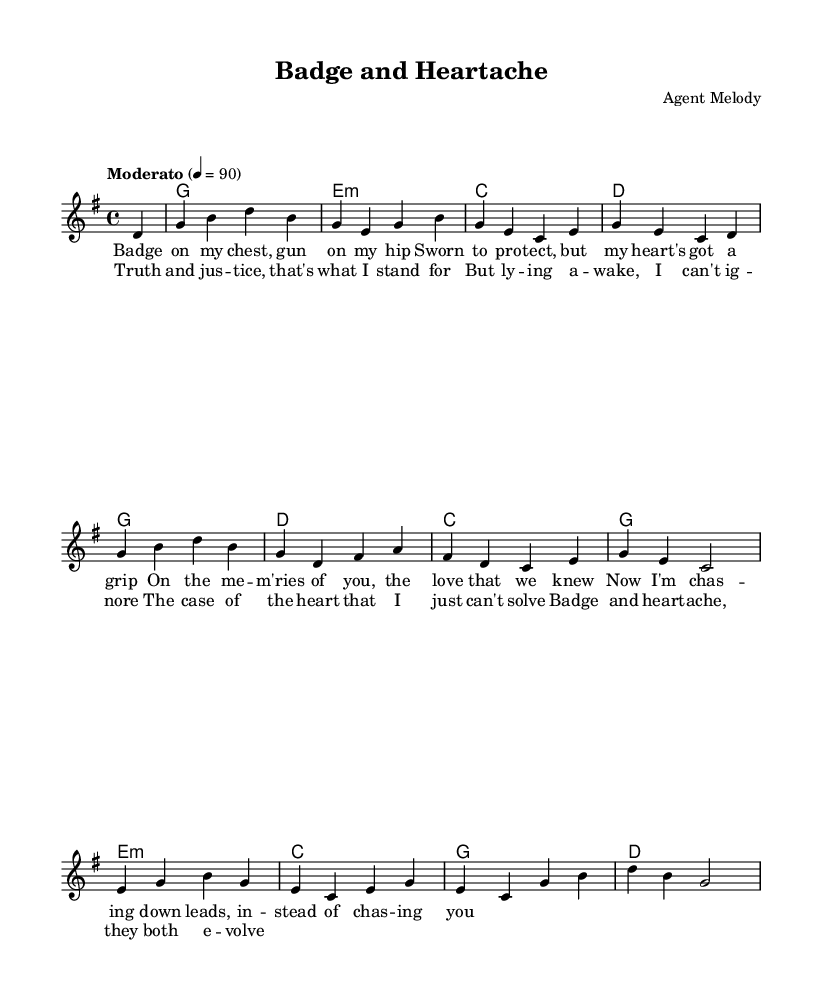What is the key signature of this music? The key signature is G major, which has one sharp (F#). This can be determined from the header or the global settings section where the key is stated.
Answer: G major What is the time signature of this music? The time signature is 4/4, which can be identified in the global section. The numerator indicates there are four beats in each measure, and the denominator indicates that each quarter note receives one beat.
Answer: 4/4 What is the tempo marking of this music? The tempo marking is "Moderato" and is set at a speed of 90 beats per minute. This is explicitly mentioned in the global settings where the tempo is defined.
Answer: Moderato How many measures are in the verse? There are eight measures in the verse, which can be counted from the music notes of the melody section associated with the verse lyrics. Each section of the melody corresponds to a measure, and the total is eight.
Answer: 8 What is the last chord in the chorus? The last chord in the chorus is G major. By analyzing the chord progression provided in the harmonies section, it can be observed that the final chord listed after the lines of the chorus is G major.
Answer: G What does the lyric “Badge on my chest, gun on my hip” suggest about the song's theme? This lyric suggests a theme related to law enforcement and personal struggles, indicating the duality of being a police officer while dealing with emotional heartache. This draws on the narrative common in contemporary country ballads involving law enforcement.
Answer: Law enforcement and heartache How does the melody relate to the emotional content of the lyrics? The melody follows a typical contour in ballads, using significant rises and falls that complement the emotional weight of the lyrics. The choice of notes and their progression supports the storytelling aspect, enhancing the feelings of longing and conflict presented in the lyrics.
Answer: Enhances emotional weight 